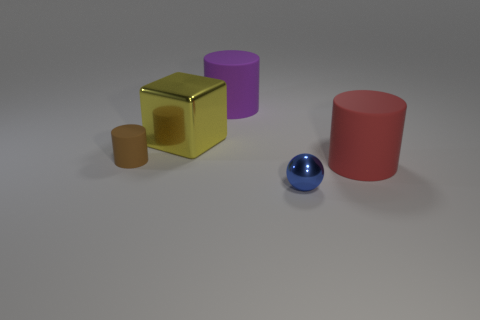Subtract all yellow cylinders. Subtract all blue spheres. How many cylinders are left? 3 Add 1 big gray cubes. How many objects exist? 6 Subtract all spheres. How many objects are left? 4 Subtract all tiny yellow objects. Subtract all matte cylinders. How many objects are left? 2 Add 1 tiny cylinders. How many tiny cylinders are left? 2 Add 5 small green metallic spheres. How many small green metallic spheres exist? 5 Subtract 0 cyan blocks. How many objects are left? 5 